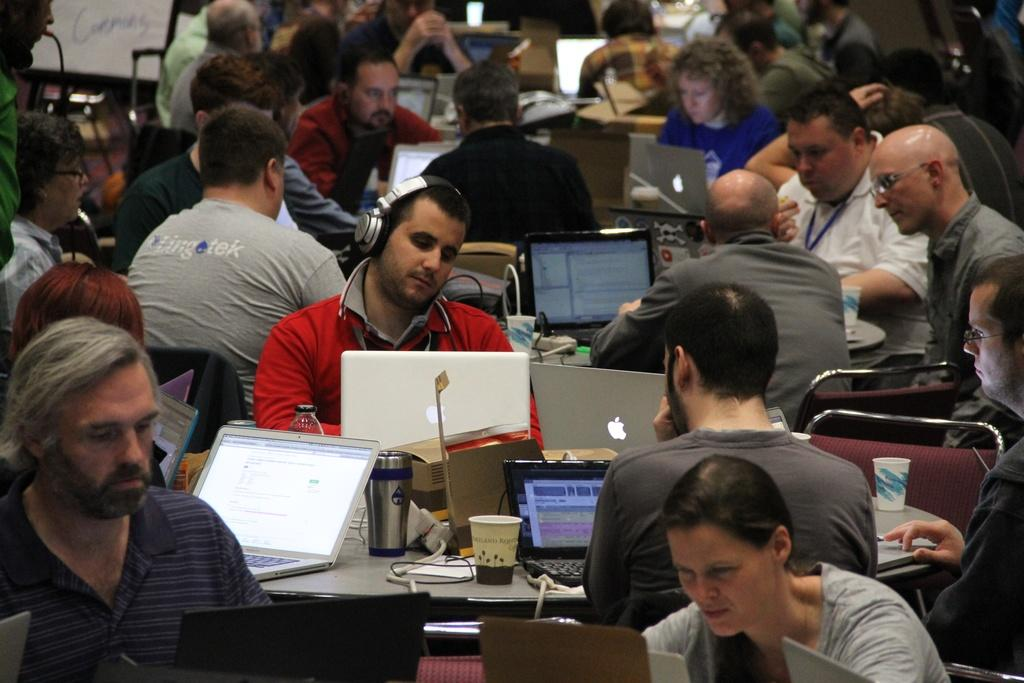What are the persons in the image doing? The persons in the image are sitting on chairs. Where are the chairs located in relation to the table? The chairs are in front of the table. What items can be seen on the table? There are bottles, glasses, and laptops on the table. What type of flower is being rewarded by the father in the image? There is no flower or father present in the image. 